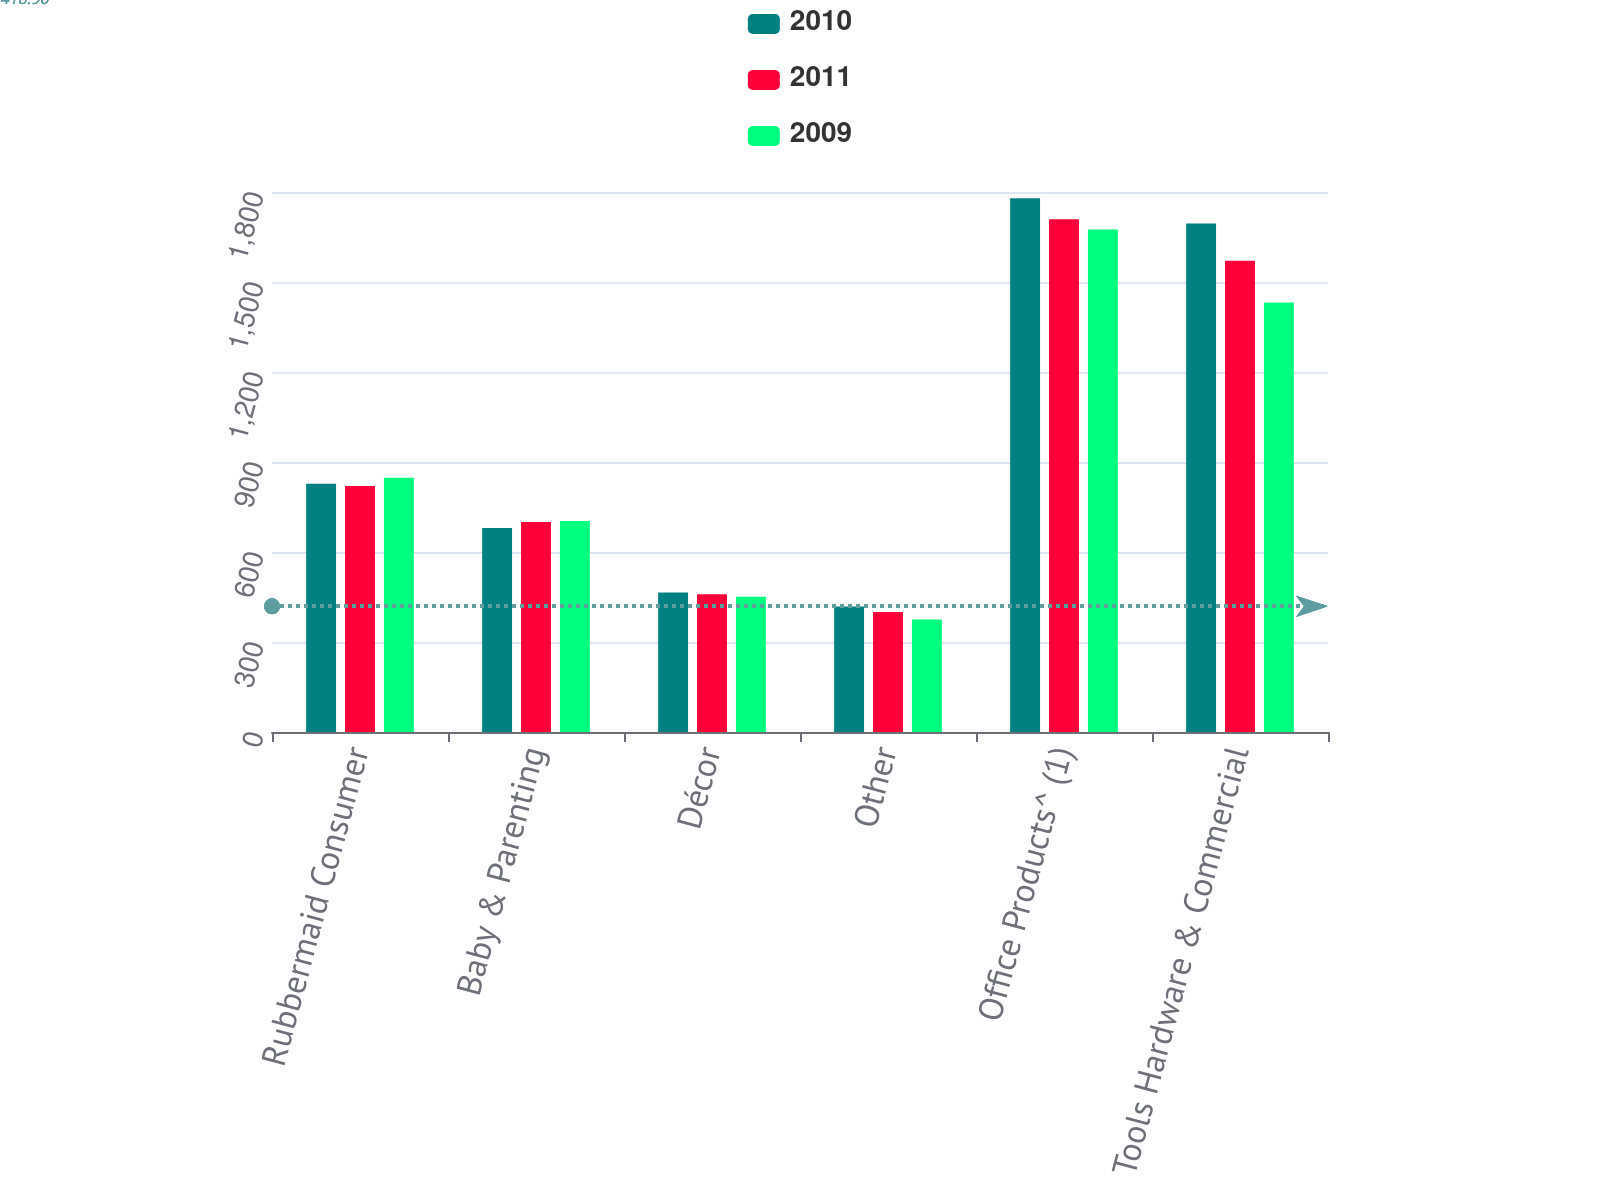Convert chart. <chart><loc_0><loc_0><loc_500><loc_500><stacked_bar_chart><ecel><fcel>Rubbermaid Consumer<fcel>Baby & Parenting<fcel>Décor<fcel>Other<fcel>Office Products^ (1)<fcel>Tools Hardware & Commercial<nl><fcel>2010<fcel>827.2<fcel>680.4<fcel>464.8<fcel>418.1<fcel>1778.8<fcel>1695.3<nl><fcel>2011<fcel>819.7<fcel>700.2<fcel>458.8<fcel>399.7<fcel>1708.9<fcel>1570.9<nl><fcel>2009<fcel>847.7<fcel>703.6<fcel>450.9<fcel>375<fcel>1674.7<fcel>1431.5<nl></chart> 